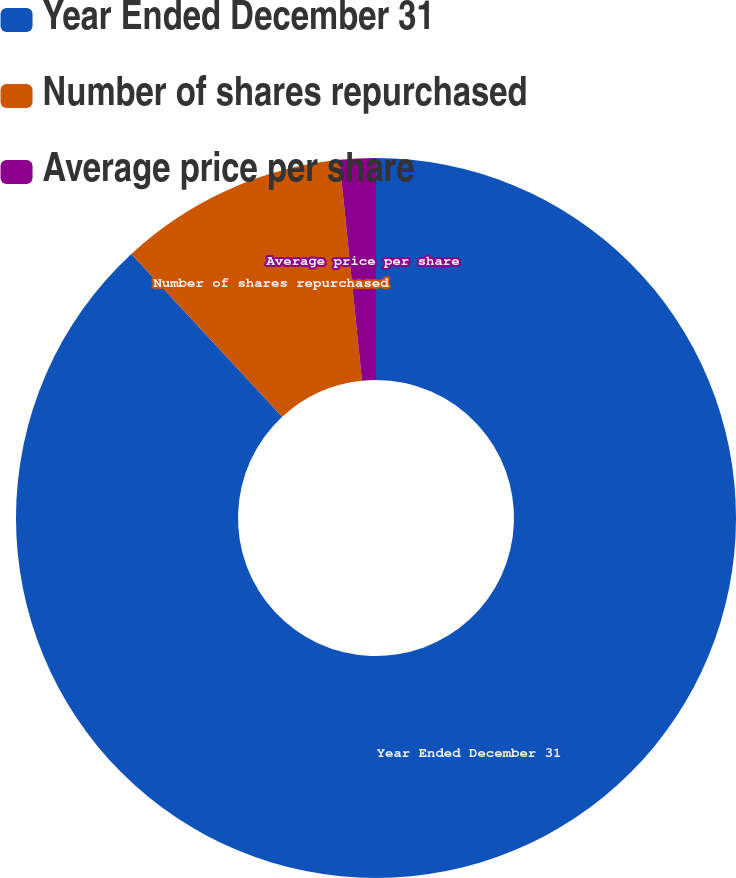Convert chart. <chart><loc_0><loc_0><loc_500><loc_500><pie_chart><fcel>Year Ended December 31<fcel>Number of shares repurchased<fcel>Average price per share<nl><fcel>88.1%<fcel>10.27%<fcel>1.62%<nl></chart> 